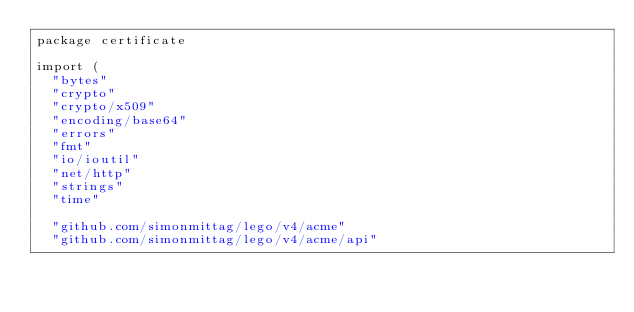<code> <loc_0><loc_0><loc_500><loc_500><_Go_>package certificate

import (
	"bytes"
	"crypto"
	"crypto/x509"
	"encoding/base64"
	"errors"
	"fmt"
	"io/ioutil"
	"net/http"
	"strings"
	"time"

	"github.com/simonmittag/lego/v4/acme"
	"github.com/simonmittag/lego/v4/acme/api"</code> 